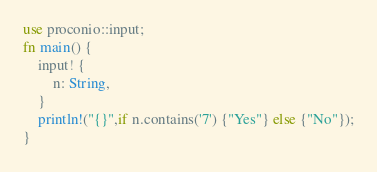<code> <loc_0><loc_0><loc_500><loc_500><_Rust_>use proconio::input;
fn main() {
    input! {
        n: String,
    }
    println!("{}",if n.contains('7') {"Yes"} else {"No"});
}</code> 